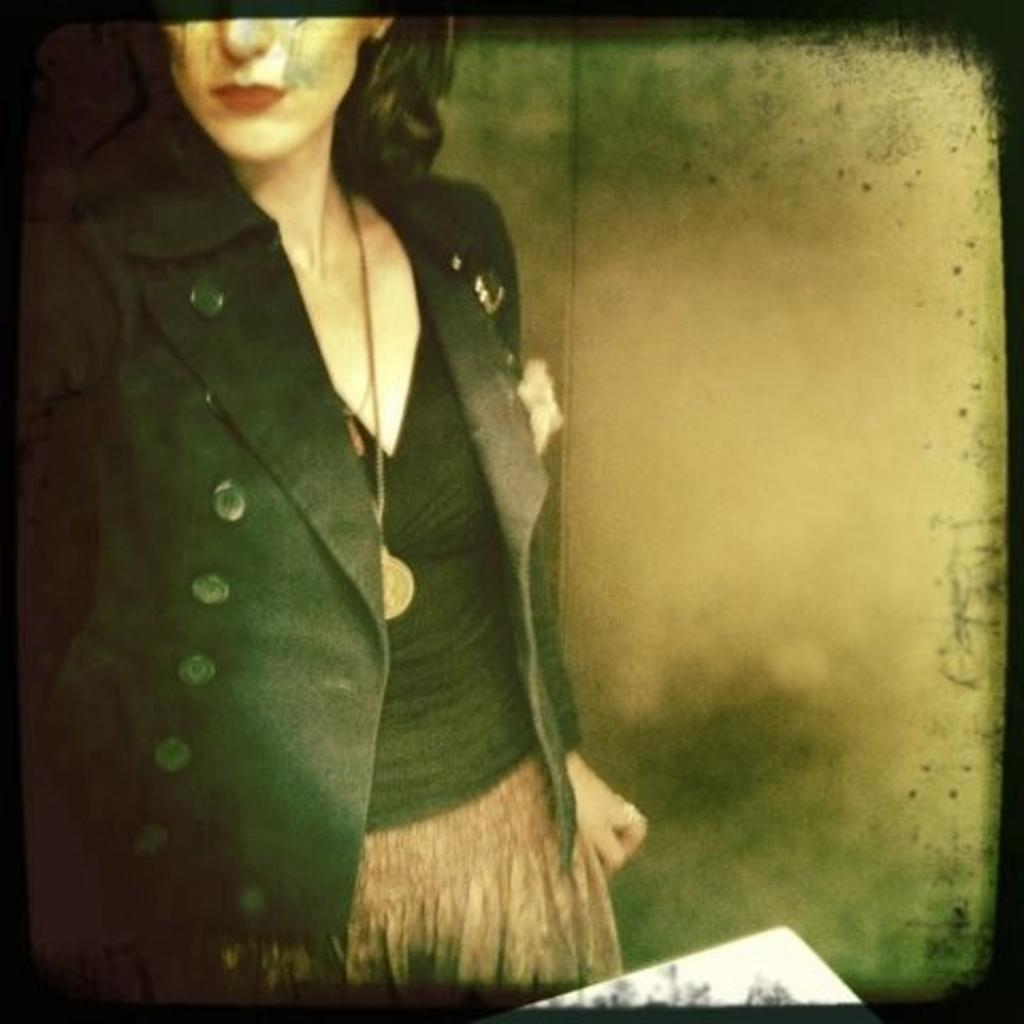What is the main object in the image? There is a screen in the image. What can be seen on the screen? A woman is visible on the screen. Can you describe the woman's appearance? The woman is wearing clothes and a neck chain. What type of poison is the woman holding in the image? There is no poison present in the image; the woman is wearing a neck chain. What action is the woman performing in the image? The image does not show the woman performing any action; she is simply visible on the screen. 